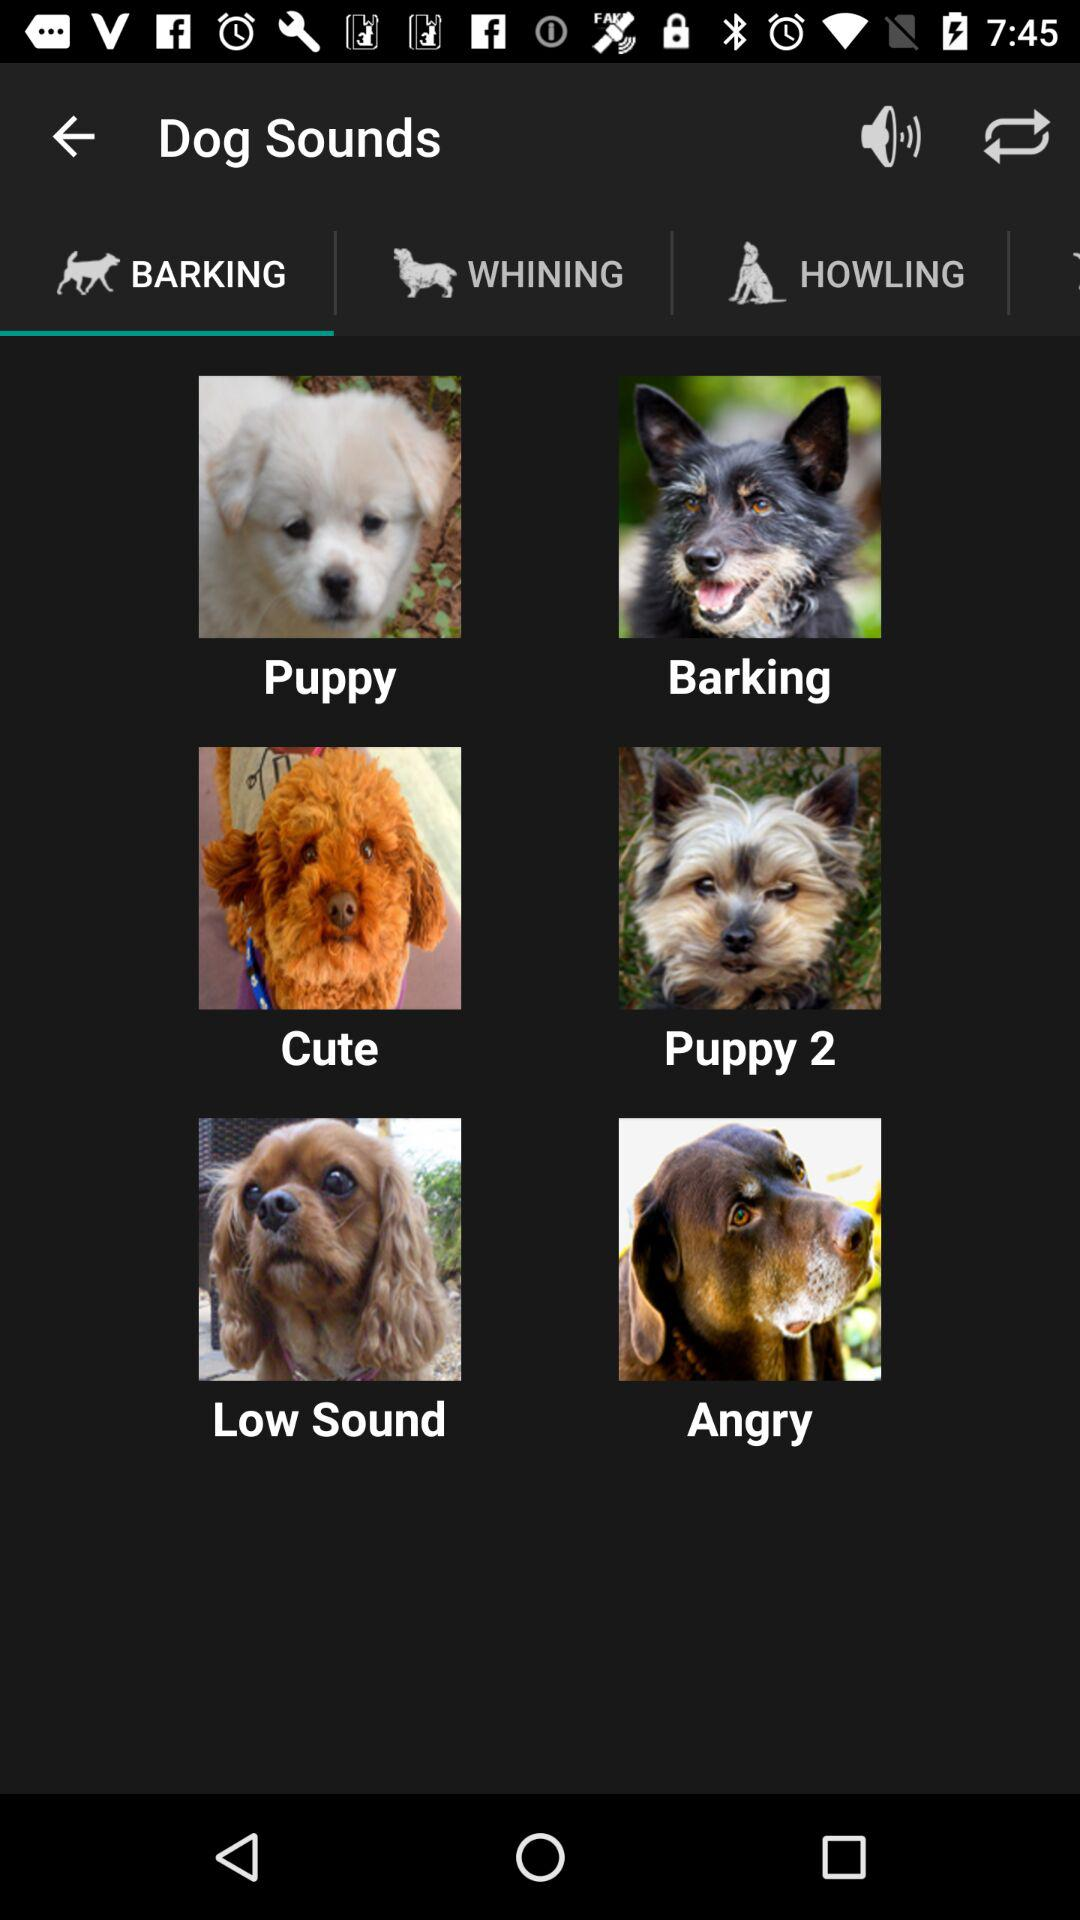What are the different barking sounds available? The different barking sounds available are "Puppy", "Barking", "Cute", "Puppy2", "Low Sound", and "Angry". 